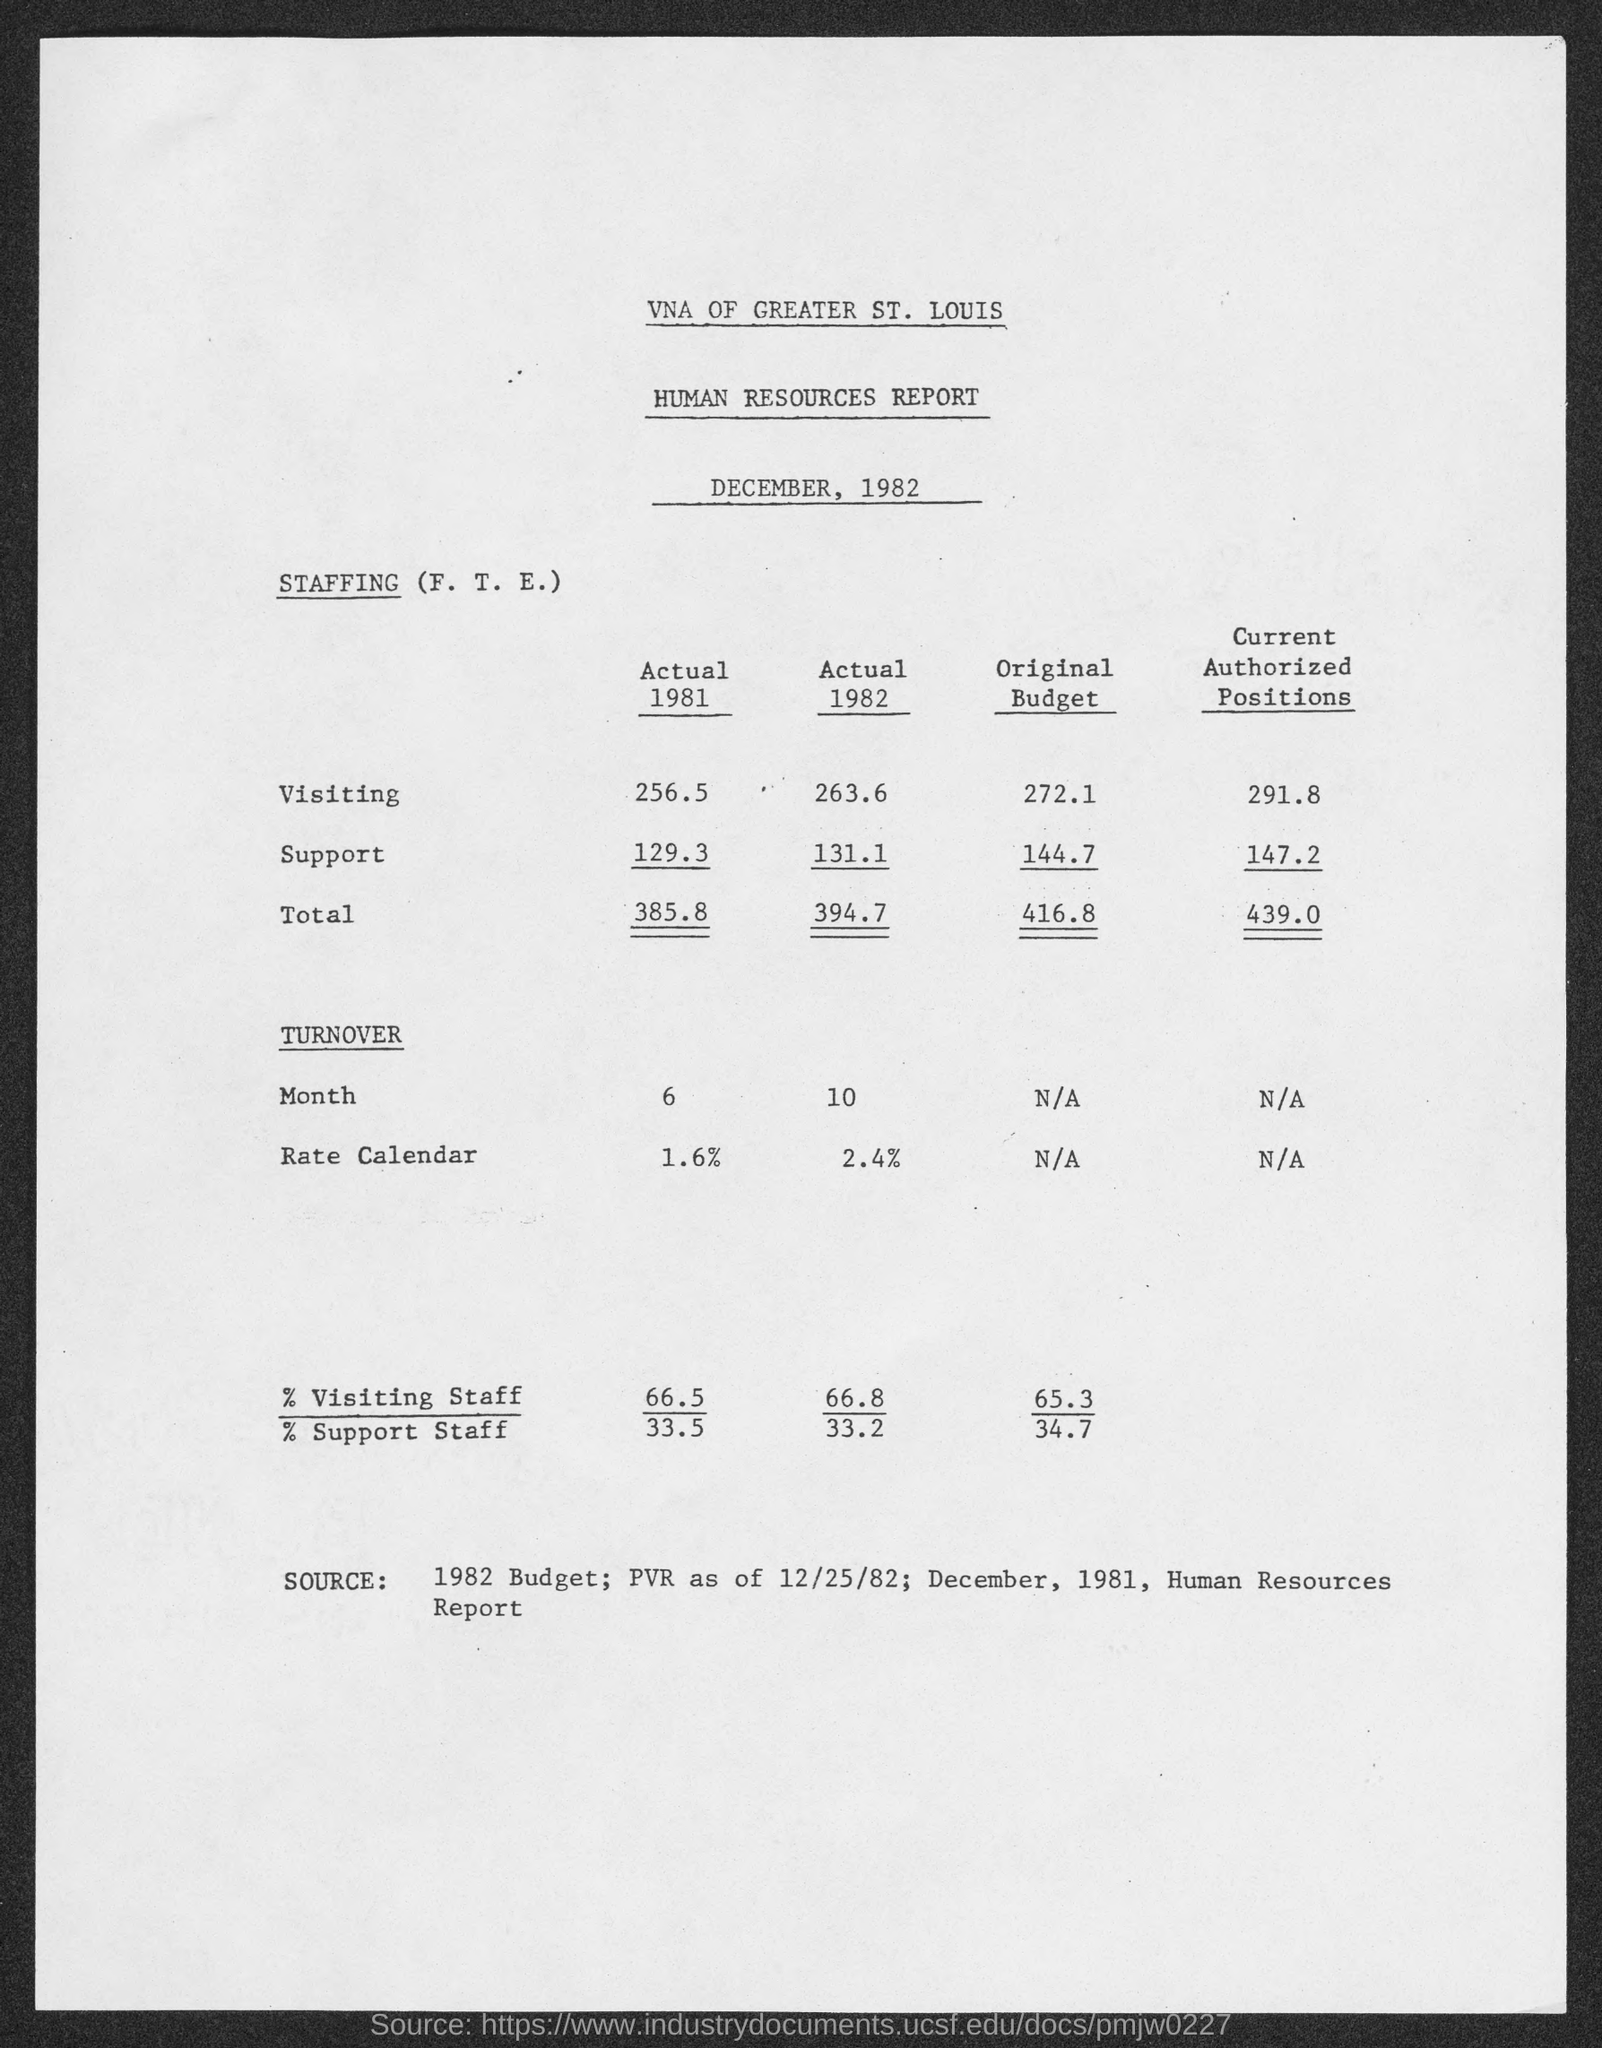Indicate a few pertinent items in this graphic. The second title in the document is "Human Resources Report.. The first title in the document is 'VNA of Greater St. Louis.' In the year 1981, the percentage of support staff was 33.5%. In the year 1981, the percentage of visiting staff was 66.5%. 